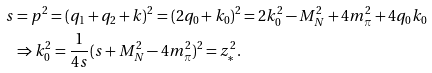Convert formula to latex. <formula><loc_0><loc_0><loc_500><loc_500>s & = p ^ { 2 } = ( q _ { 1 } + q _ { 2 } + k ) ^ { 2 } = ( 2 q _ { 0 } + k _ { 0 } ) ^ { 2 } = 2 k _ { 0 } ^ { 2 } - M _ { N } ^ { 2 } + 4 m _ { \pi } ^ { 2 } + 4 q _ { 0 } k _ { 0 } \\ & \Rightarrow k _ { 0 } ^ { 2 } = \frac { 1 } { 4 s } ( s + M _ { N } ^ { 2 } - 4 m ^ { 2 } _ { \pi } ) ^ { 2 } = z _ { * } ^ { 2 } .</formula> 